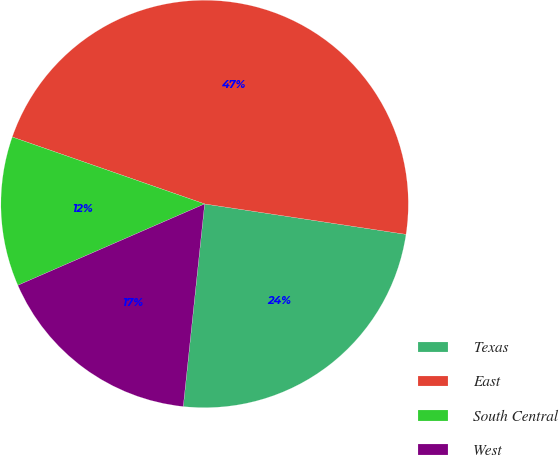Convert chart. <chart><loc_0><loc_0><loc_500><loc_500><pie_chart><fcel>Texas<fcel>East<fcel>South Central<fcel>West<nl><fcel>24.29%<fcel>47.06%<fcel>11.87%<fcel>16.79%<nl></chart> 